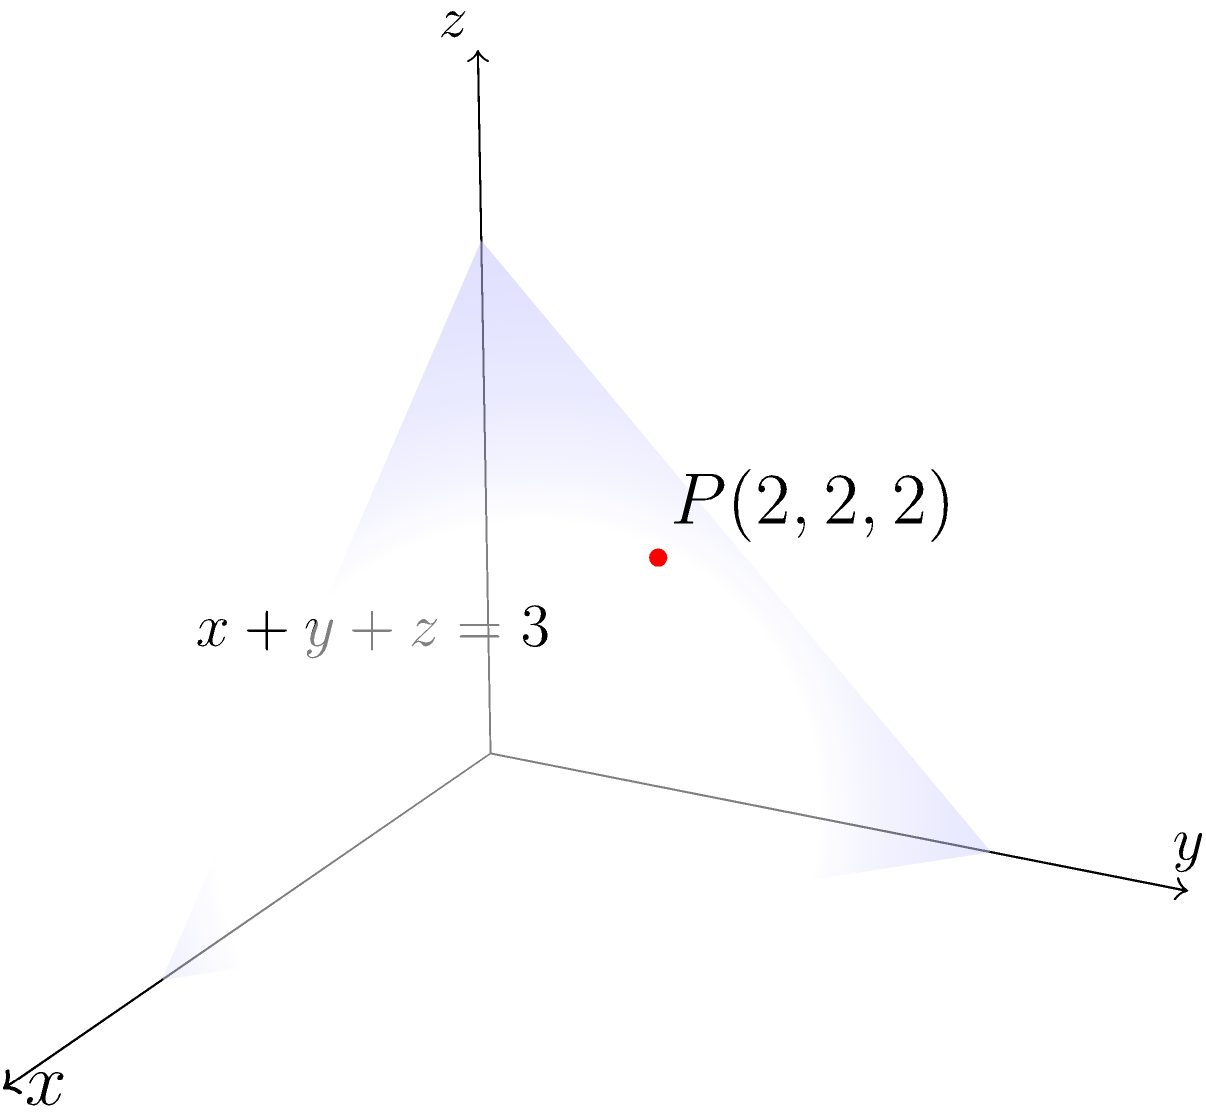As a frustrated VHI insurance holder, you've been dealing with complex claim calculations. To distract yourself, you decide to tackle a geometry problem. Given a point $P(2,2,2)$ and a plane with equation $x+y+z=3$ in 3D space, determine the shortest distance from the point to the plane. How might this remind you of the shortest path to resolving insurance disputes? Let's approach this step-by-step, much like we should approach insurance claim resolutions:

1) The general formula for the distance $d$ from a point $(x_0,y_0,z_0)$ to a plane $Ax+By+Cz+D=0$ is:

   $$d = \frac{|Ax_0 + By_0 + Cz_0 + D|}{\sqrt{A^2 + B^2 + C^2}}$$

2) In our case, the plane equation $x+y+z=3$ can be rewritten as $x+y+z-3=0$. So, $A=1$, $B=1$, $C=1$, and $D=-3$.

3) The point $P$ has coordinates $(x_0,y_0,z_0) = (2,2,2)$.

4) Substituting these values into the formula:

   $$d = \frac{|1(2) + 1(2) + 1(2) - 3|}{\sqrt{1^2 + 1^2 + 1^2}}$$

5) Simplify:
   $$d = \frac{|6 - 3|}{\sqrt{3}} = \frac{3}{\sqrt{3}}$$

6) Simplify further:
   $$d = \frac{3}{\sqrt{3}} = \sqrt{3}$$

Just as we've found the shortest distance here, we should always seek the most direct path to resolving insurance disputes, avoiding unnecessary complications.
Answer: $\sqrt{3}$ 